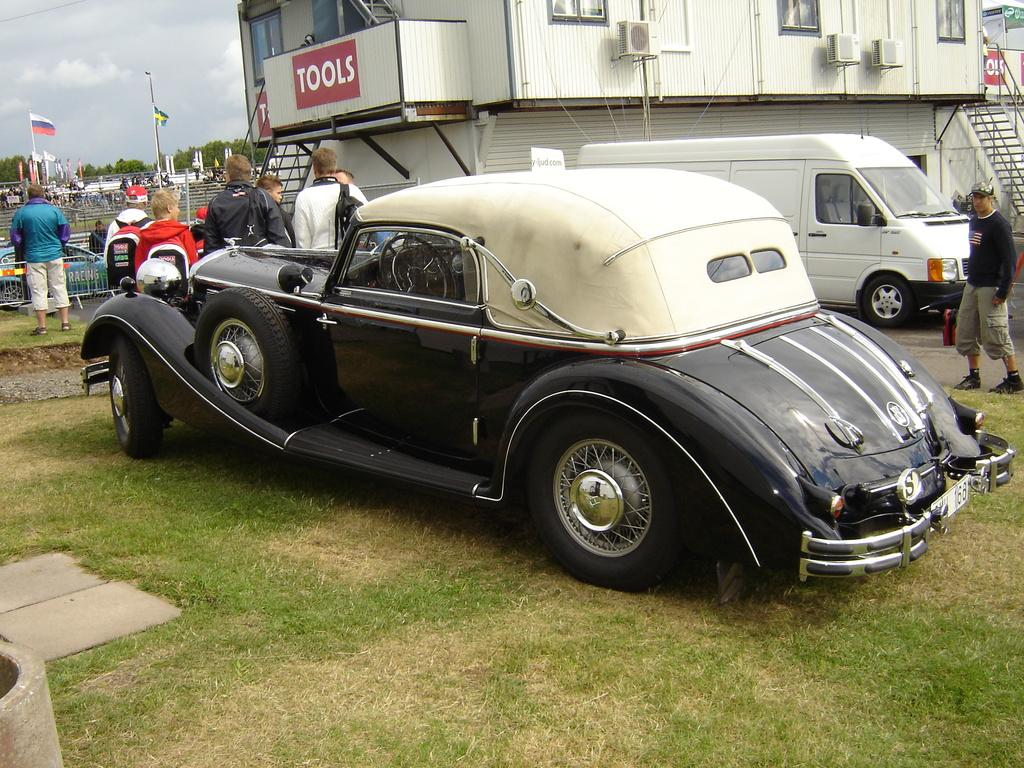What is the main subject in the foreground of the image? There is a car in the foreground of the image. Where is the car located? The car is on a grassland. Can you describe the people in the image? There are people in the image, but their specific actions or appearances are not mentioned in the facts. What type of boundaries can be seen in the image? The facts do not specify the type of boundaries, only that they are visible. What else can be seen in the background of the image? In the background, there are vehicles, posters, a building structure, trees, flags, and the sky. What type of marble is being used to construct the giant's statue in the image? There is no mention of a giant or a statue in the image, so it is not possible to answer this question. 